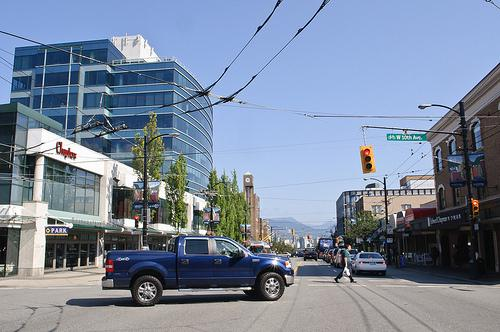Question: how would the sky be described?
Choices:
A. Dark and gray.
B. Blue and clear.
C. Partly sunny.
D. Cloudy and dark.
Answer with the letter. Answer: B Question: where is the clock tower?
Choices:
A. About halfway down the left hand side of the street.
B. Two blocks away on the right.
C. Across from the school.
D. The left side of the bank.
Answer with the letter. Answer: A Question: what is in the background?
Choices:
A. Cars and trucks.
B. Snow and ice.
C. Trees and grass.
D. Mountains and sky.
Answer with the letter. Answer: D Question: when was the photo taken?
Choices:
A. Sunset.
B. Sunrise.
C. Midnight.
D. During the day.
Answer with the letter. Answer: D 